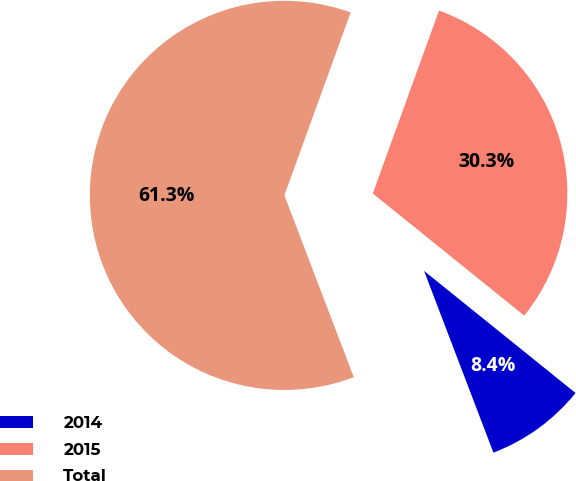<chart> <loc_0><loc_0><loc_500><loc_500><pie_chart><fcel>2014<fcel>2015<fcel>Total<nl><fcel>8.4%<fcel>30.27%<fcel>61.33%<nl></chart> 